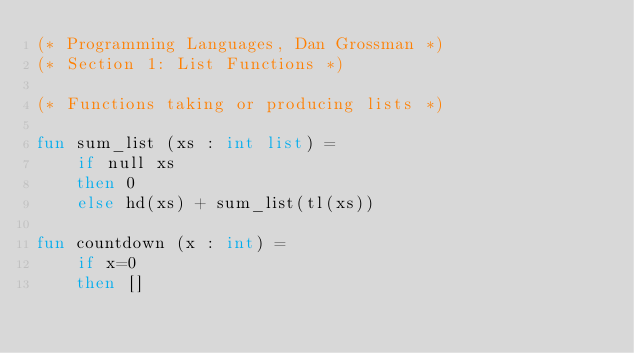Convert code to text. <code><loc_0><loc_0><loc_500><loc_500><_SML_>(* Programming Languages, Dan Grossman *)
(* Section 1: List Functions *)

(* Functions taking or producing lists *)

fun sum_list (xs : int list) =
    if null xs
    then 0
    else hd(xs) + sum_list(tl(xs))

fun countdown (x : int) =
    if x=0
    then []</code> 